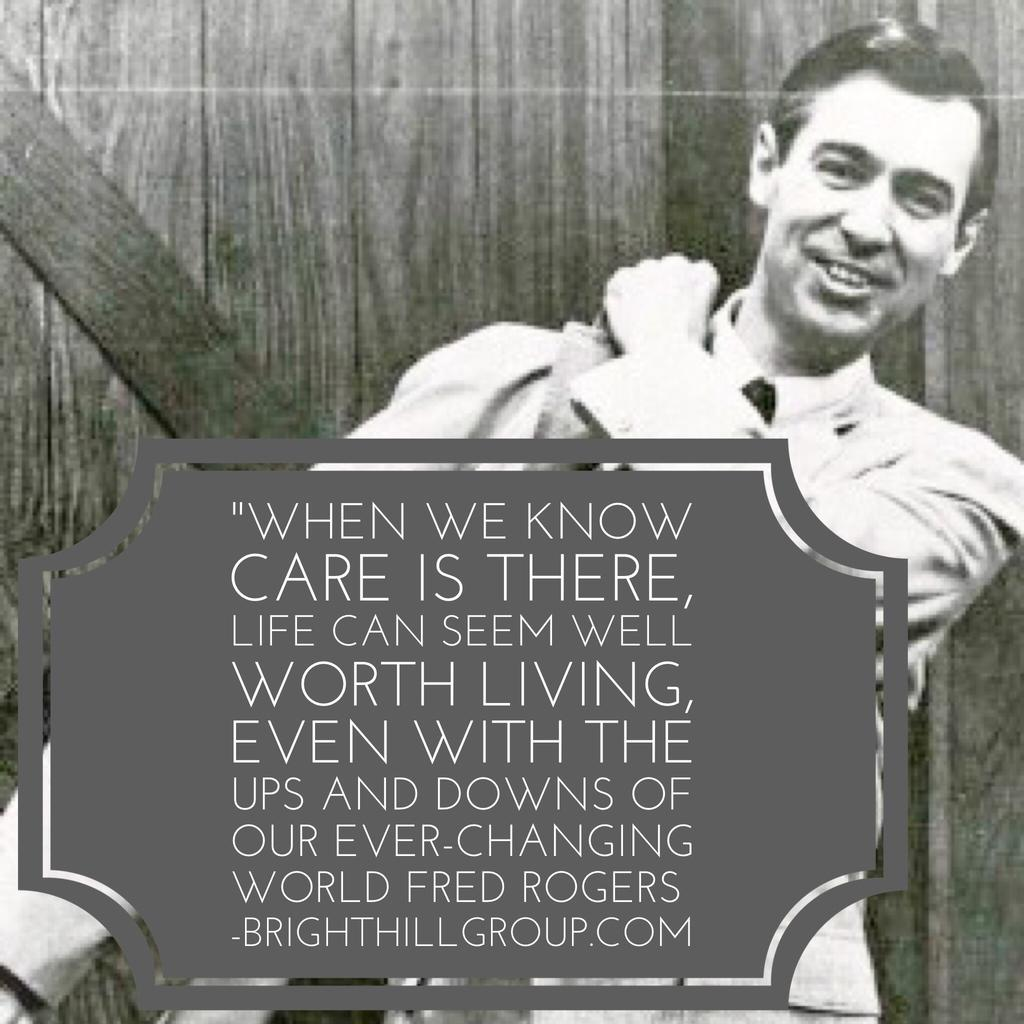What is the main subject of the image? There is a person in the image. What is the person wearing? The person is wearing a shirt. What is the person doing in the image? The person is standing and smiling. Can you describe any objects or features in the foreground of the image? There is a sticker on the glass in front of the person. What can be seen in the background of the image? There is a wooden wall in the background of the image. How many holes are visible in the person's shirt in the image? There is no mention of any holes in the person's shirt in the image. 